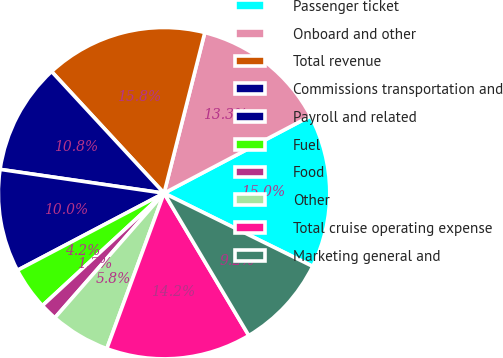Convert chart. <chart><loc_0><loc_0><loc_500><loc_500><pie_chart><fcel>Passenger ticket<fcel>Onboard and other<fcel>Total revenue<fcel>Commissions transportation and<fcel>Payroll and related<fcel>Fuel<fcel>Food<fcel>Other<fcel>Total cruise operating expense<fcel>Marketing general and<nl><fcel>15.0%<fcel>13.33%<fcel>15.83%<fcel>10.83%<fcel>10.0%<fcel>4.17%<fcel>1.67%<fcel>5.84%<fcel>14.16%<fcel>9.17%<nl></chart> 